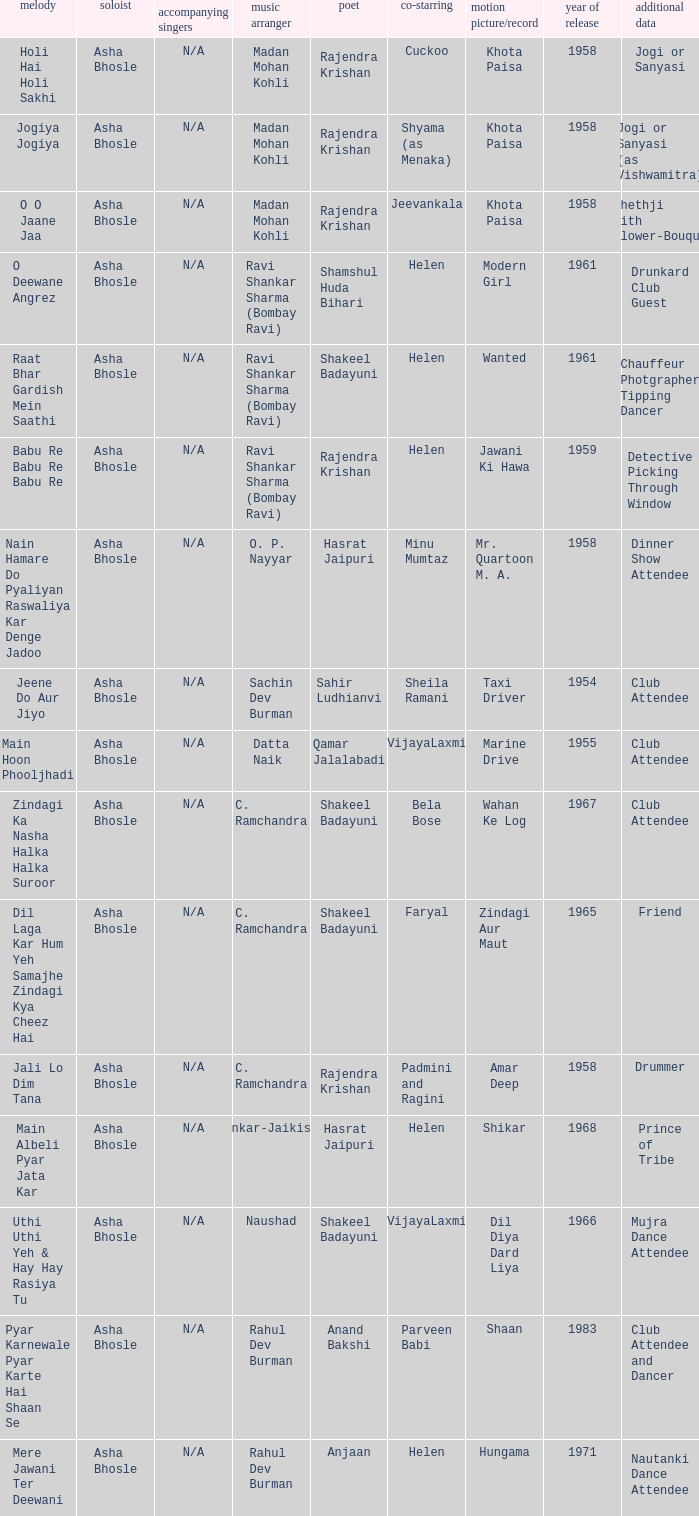What movie did Bela Bose co-star in? Wahan Ke Log. 